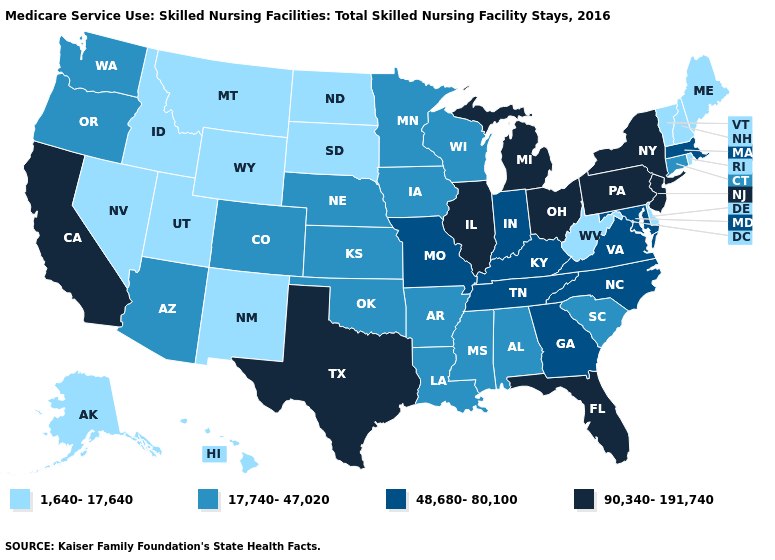Which states have the lowest value in the West?
Concise answer only. Alaska, Hawaii, Idaho, Montana, Nevada, New Mexico, Utah, Wyoming. Among the states that border Massachusetts , does Vermont have the highest value?
Keep it brief. No. What is the highest value in the USA?
Quick response, please. 90,340-191,740. What is the value of Connecticut?
Give a very brief answer. 17,740-47,020. What is the highest value in the USA?
Keep it brief. 90,340-191,740. Among the states that border Massachusetts , does New Hampshire have the lowest value?
Write a very short answer. Yes. Which states have the highest value in the USA?
Quick response, please. California, Florida, Illinois, Michigan, New Jersey, New York, Ohio, Pennsylvania, Texas. Does Montana have the lowest value in the USA?
Quick response, please. Yes. Does New York have the highest value in the Northeast?
Concise answer only. Yes. Does Virginia have the lowest value in the South?
Answer briefly. No. Does the first symbol in the legend represent the smallest category?
Answer briefly. Yes. Does the map have missing data?
Give a very brief answer. No. Among the states that border New Mexico , does Oklahoma have the highest value?
Quick response, please. No. Name the states that have a value in the range 17,740-47,020?
Short answer required. Alabama, Arizona, Arkansas, Colorado, Connecticut, Iowa, Kansas, Louisiana, Minnesota, Mississippi, Nebraska, Oklahoma, Oregon, South Carolina, Washington, Wisconsin. Does Arkansas have the lowest value in the USA?
Keep it brief. No. 